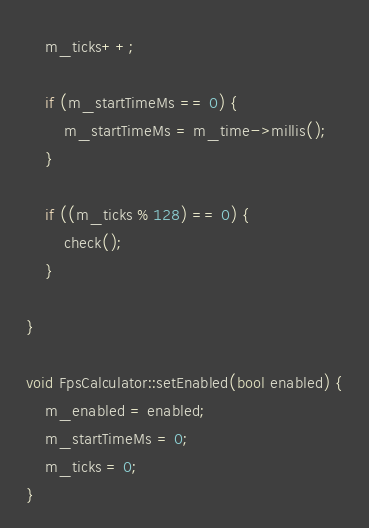<code> <loc_0><loc_0><loc_500><loc_500><_C++_>    m_ticks++;

    if (m_startTimeMs == 0) {
        m_startTimeMs = m_time->millis();
    }

    if ((m_ticks % 128) == 0) {
        check();
    }

}

void FpsCalculator::setEnabled(bool enabled) {
    m_enabled = enabled;
    m_startTimeMs = 0;
    m_ticks = 0;
}
</code> 